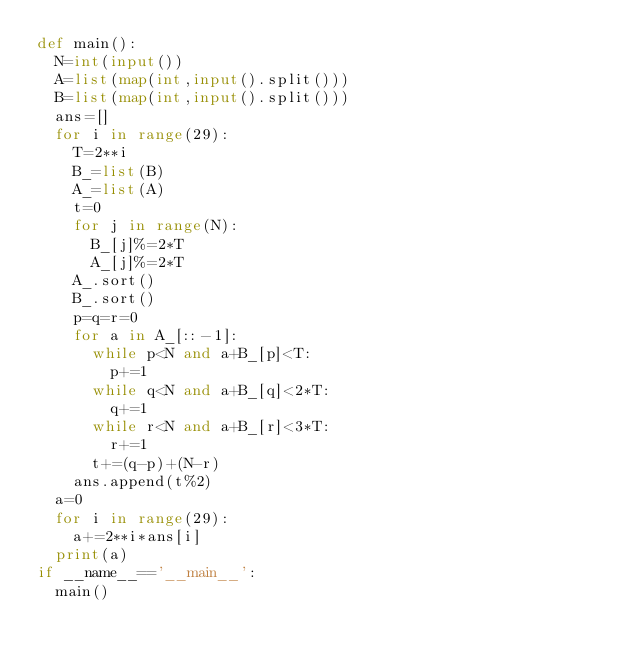Convert code to text. <code><loc_0><loc_0><loc_500><loc_500><_Python_>def main():
  N=int(input())
  A=list(map(int,input().split()))
  B=list(map(int,input().split()))
  ans=[]
  for i in range(29):
    T=2**i
    B_=list(B)
    A_=list(A)
    t=0
    for j in range(N):
      B_[j]%=2*T
      A_[j]%=2*T
    A_.sort()
    B_.sort()
    p=q=r=0
    for a in A_[::-1]:
      while p<N and a+B_[p]<T:
        p+=1
      while q<N and a+B_[q]<2*T:
        q+=1
      while r<N and a+B_[r]<3*T:
        r+=1
      t+=(q-p)+(N-r)
    ans.append(t%2)
  a=0
  for i in range(29):
    a+=2**i*ans[i]
  print(a)
if __name__=='__main__':
  main()
</code> 